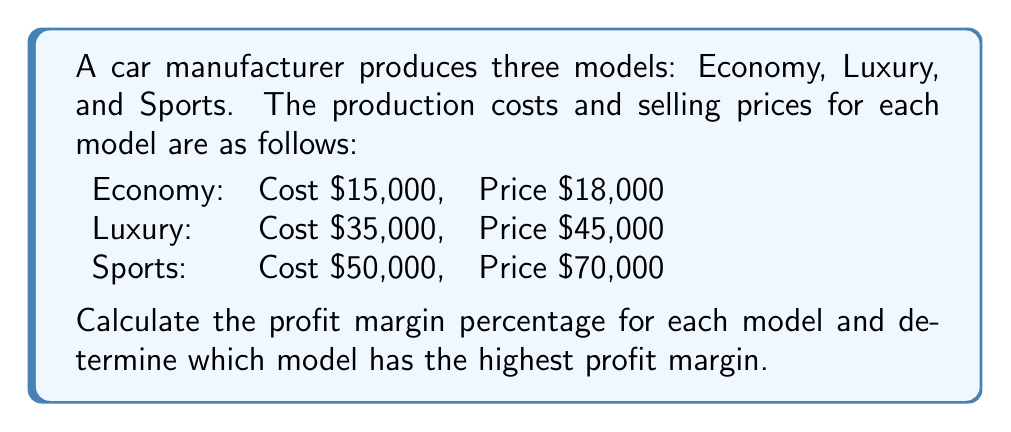Solve this math problem. To calculate the profit margin percentage for each model, we'll use the formula:

$$\text{Profit Margin} = \frac{\text{Selling Price} - \text{Cost}}{\text{Selling Price}} \times 100\%$$

1. Economy model:
   $$\text{Profit Margin}_{\text{Economy}} = \frac{18,000 - 15,000}{18,000} \times 100\% = \frac{3,000}{18,000} \times 100\% = 16.67\%$$

2. Luxury model:
   $$\text{Profit Margin}_{\text{Luxury}} = \frac{45,000 - 35,000}{45,000} \times 100\% = \frac{10,000}{45,000} \times 100\% = 22.22\%$$

3. Sports model:
   $$\text{Profit Margin}_{\text{Sports}} = \frac{70,000 - 50,000}{70,000} \times 100\% = \frac{20,000}{70,000} \times 100\% = 28.57\%$$

Comparing the profit margins:
Economy: 16.67%
Luxury: 22.22%
Sports: 28.57%

The Sports model has the highest profit margin at 28.57%.
Answer: Sports model: 28.57% 